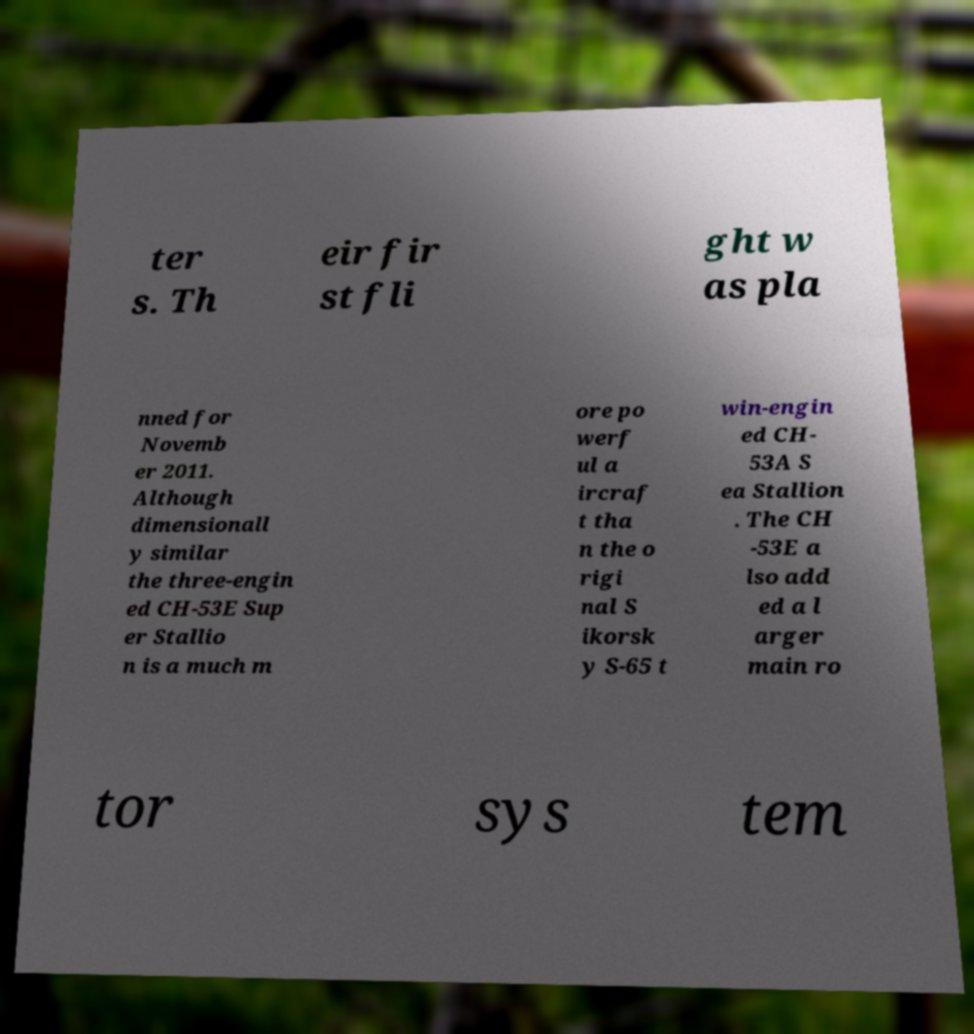Can you read and provide the text displayed in the image?This photo seems to have some interesting text. Can you extract and type it out for me? ter s. Th eir fir st fli ght w as pla nned for Novemb er 2011. Although dimensionall y similar the three-engin ed CH-53E Sup er Stallio n is a much m ore po werf ul a ircraf t tha n the o rigi nal S ikorsk y S-65 t win-engin ed CH- 53A S ea Stallion . The CH -53E a lso add ed a l arger main ro tor sys tem 